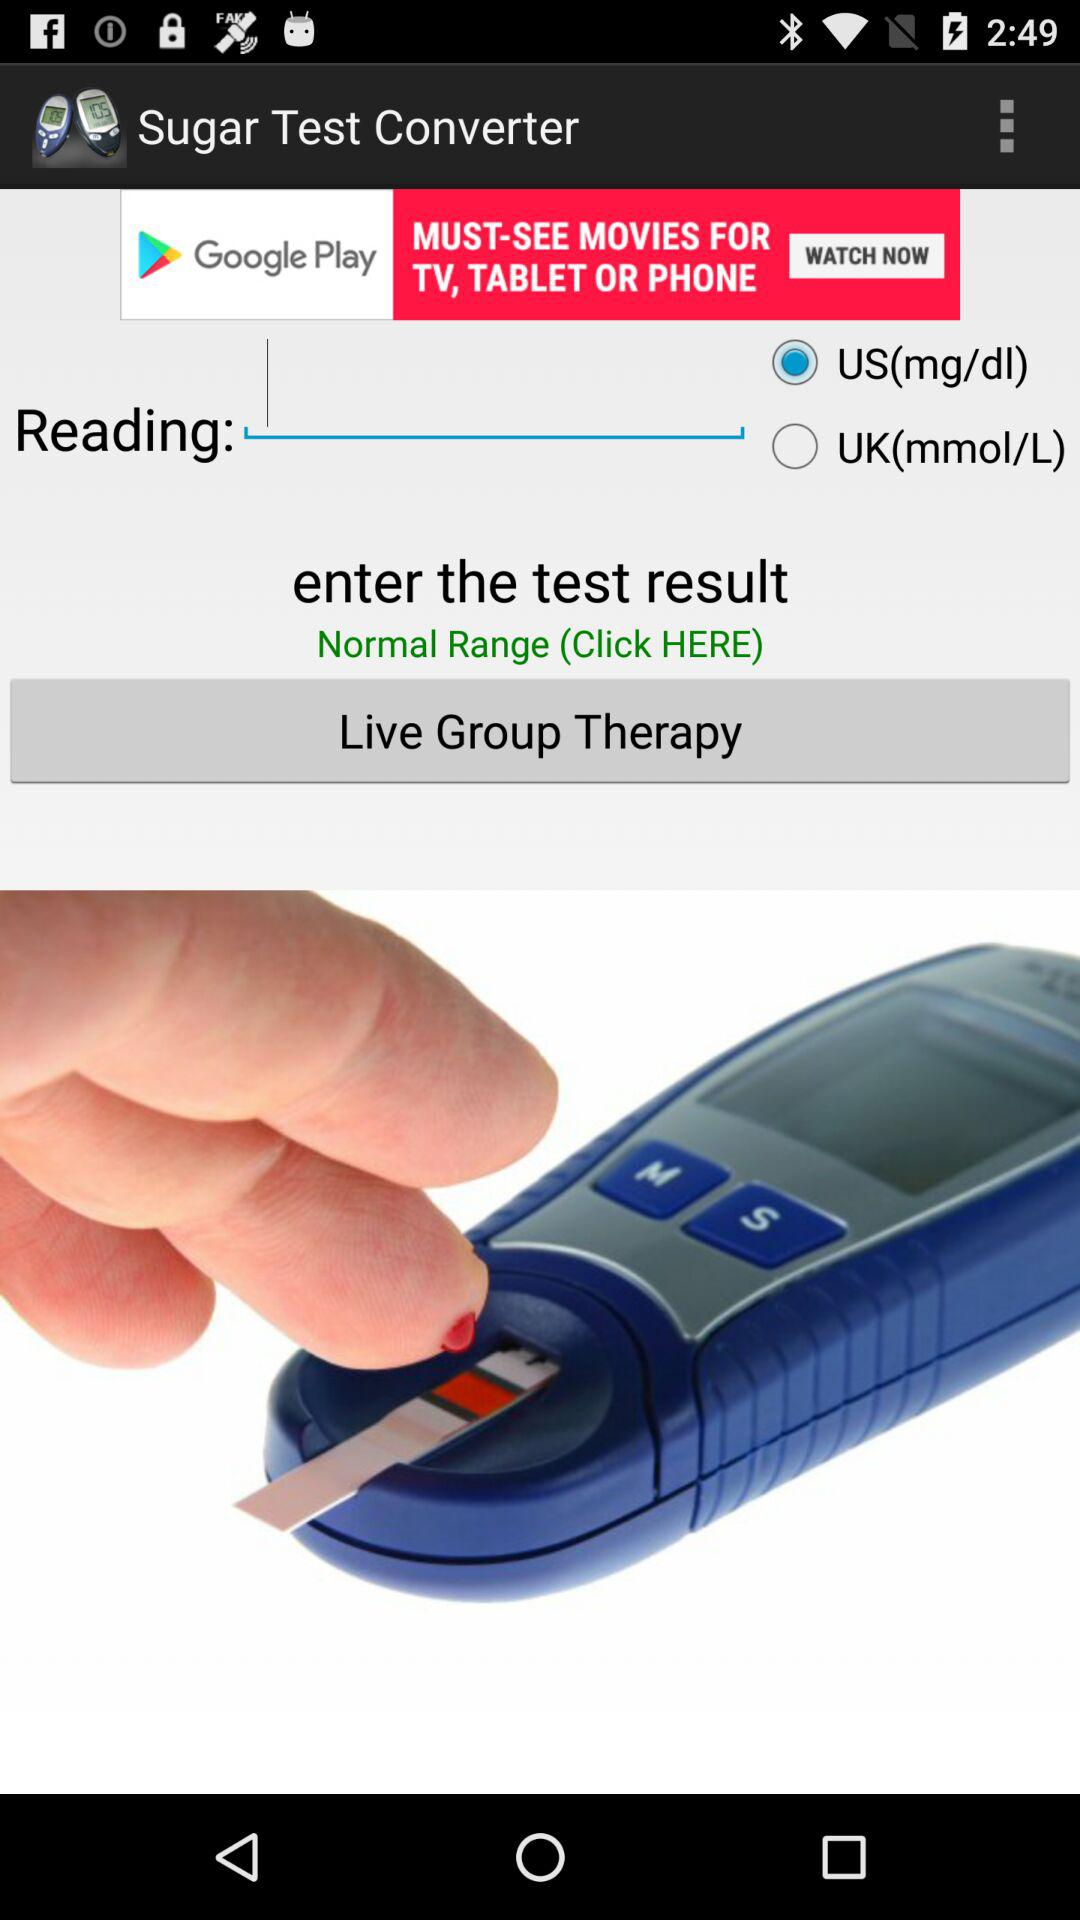What is the application name? The application name is "Sugar Test Converter". 